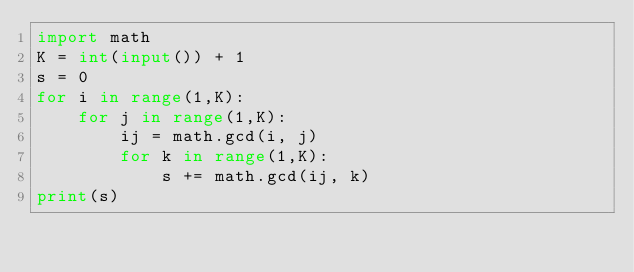Convert code to text. <code><loc_0><loc_0><loc_500><loc_500><_Python_>import math
K = int(input()) + 1
s = 0
for i in range(1,K):
    for j in range(1,K):
        ij = math.gcd(i, j)
        for k in range(1,K):
            s += math.gcd(ij, k)
print(s)

</code> 